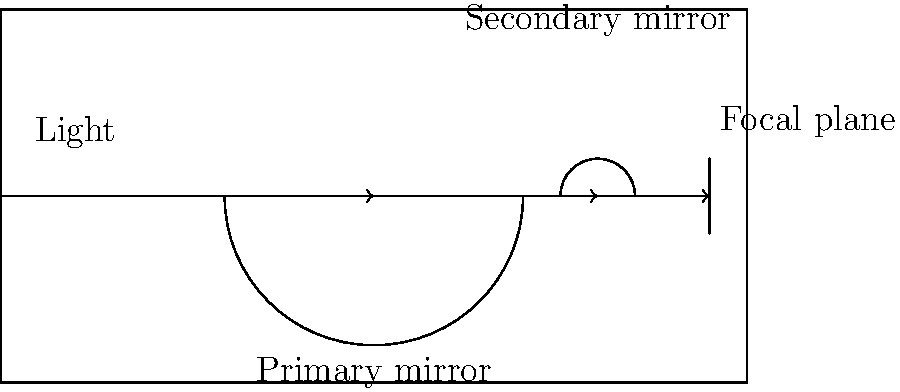As a software developer with an interest in technology, you're intrigued by the optical systems in telescopes. In the diagram above, which component reflects incoming light to the secondary mirror in a reflecting telescope? To understand the functioning of a reflecting telescope, let's break down the light path:

1. Light enters the telescope from the left side of the diagram.
2. The first major optical component the light encounters is the large curved mirror at the bottom of the telescope. This is the primary mirror.
3. The primary mirror reflects the incoming light towards the top of the telescope.
4. At the top, there's a smaller mirror called the secondary mirror.
5. The secondary mirror then reflects the light towards the focal plane at the right side of the telescope.

The key component in this system is the primary mirror. It's responsible for gathering a large amount of light and reflecting it to the secondary mirror. The primary mirror is typically concave and much larger than the secondary mirror, allowing it to collect more light and increase the telescope's light-gathering power.

In the context of software development, this optical system can be likened to a data pipeline where the primary mirror acts as the initial data collector, similar to how an API might gather raw data in a software system.
Answer: Primary mirror 